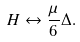<formula> <loc_0><loc_0><loc_500><loc_500>H \leftrightarrow \frac { \mu } { 6 } \Delta .</formula> 